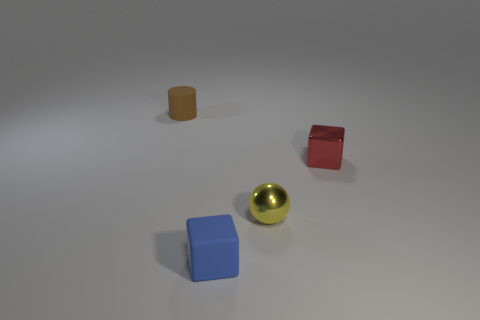Add 4 green rubber spheres. How many objects exist? 8 Subtract all red cubes. How many cubes are left? 1 Subtract 1 spheres. How many spheres are left? 0 Subtract all purple blocks. Subtract all cyan cylinders. How many blocks are left? 2 Subtract all cyan balls. How many blue blocks are left? 1 Subtract all brown rubber cylinders. Subtract all brown cylinders. How many objects are left? 2 Add 3 tiny rubber cylinders. How many tiny rubber cylinders are left? 4 Add 3 small red metallic cylinders. How many small red metallic cylinders exist? 3 Subtract 0 brown blocks. How many objects are left? 4 Subtract all cylinders. How many objects are left? 3 